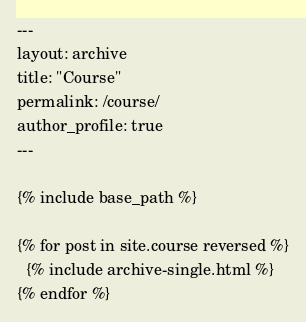<code> <loc_0><loc_0><loc_500><loc_500><_HTML_>---
layout: archive
title: "Course"
permalink: /course/
author_profile: true
---

{% include base_path %}

{% for post in site.course reversed %}
  {% include archive-single.html %}
{% endfor %}
</code> 